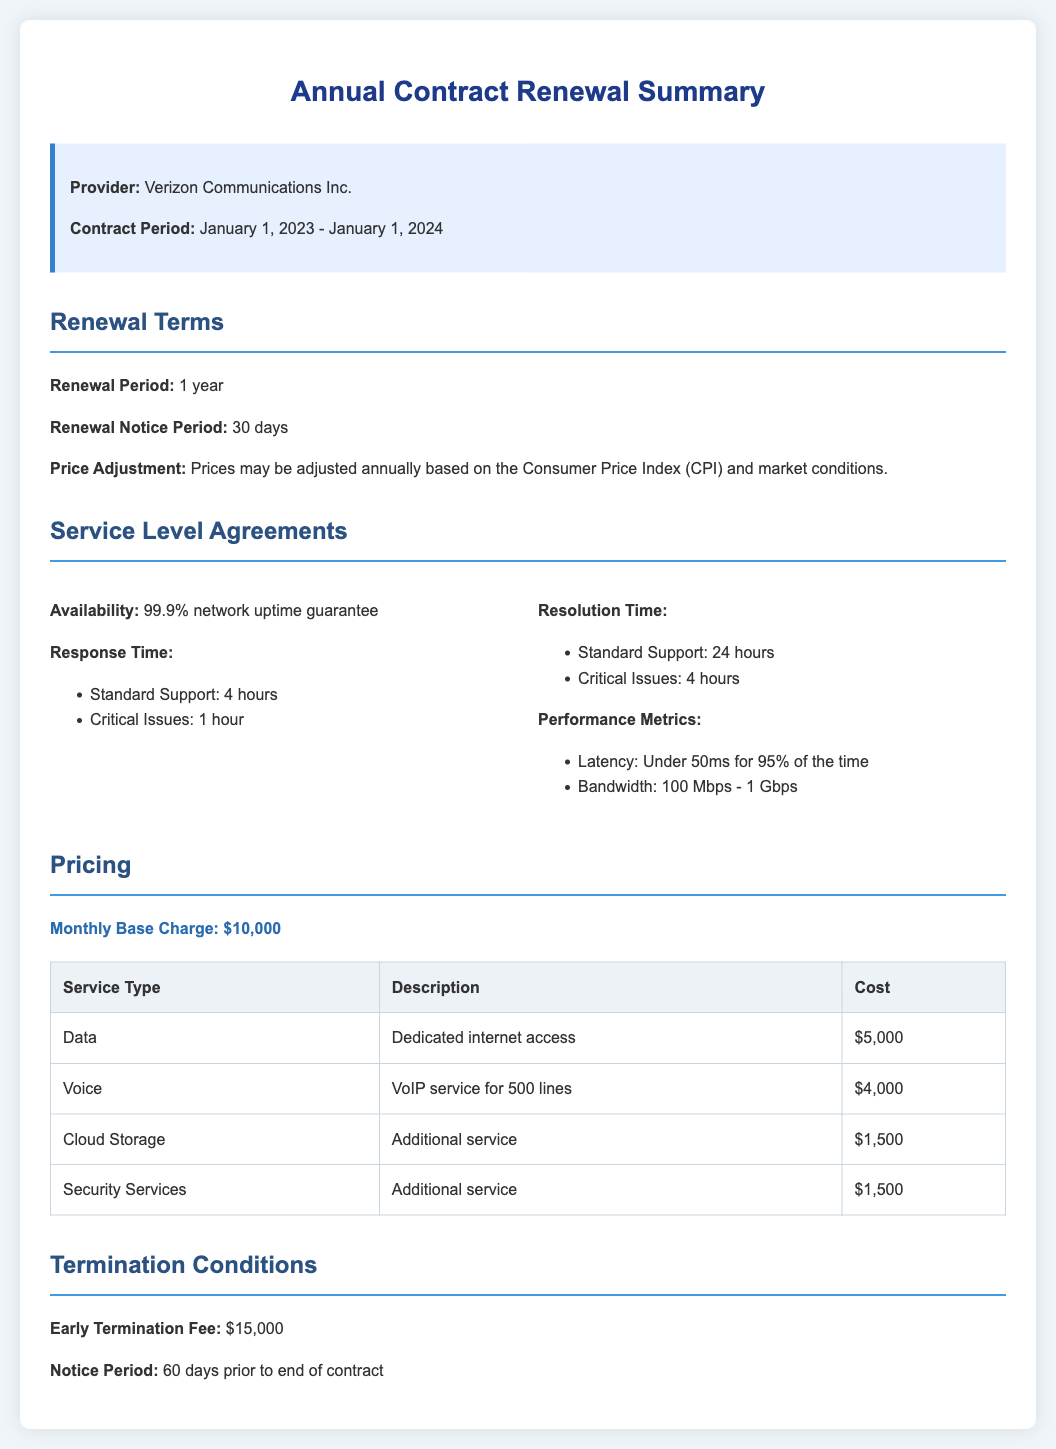What is the contract period? The contract period is specified as January 1, 2023 to January 1, 2024.
Answer: January 1, 2023 - January 1, 2024 What is the early termination fee? The early termination fee is explicitly mentioned in the document.
Answer: $15,000 What is the monthly base charge? The monthly base charge is highlighted in the pricing section of the document.
Answer: $10,000 What is the availability guarantee? The document states the network uptime guarantee under service level agreements.
Answer: 99.9% network uptime guarantee How long is the renewal notice period? The notice period for renewal is stated clearly in the renewal terms.
Answer: 30 days What is the response time for critical issues? The response time for critical issues is detailed in the service level agreements.
Answer: 1 hour What are the performance metrics for latency? The document provides performance metrics that include latency details.
Answer: Under 50ms for 95% of the time What additional service costs $1,500? The document lists services along with their costs, specifically mentioning additional services.
Answer: Cloud Storage and Security Services What is the required notice period to terminate the contract? The notice period for termination is explicitly mentioned under termination conditions.
Answer: 60 days prior to end of contract 